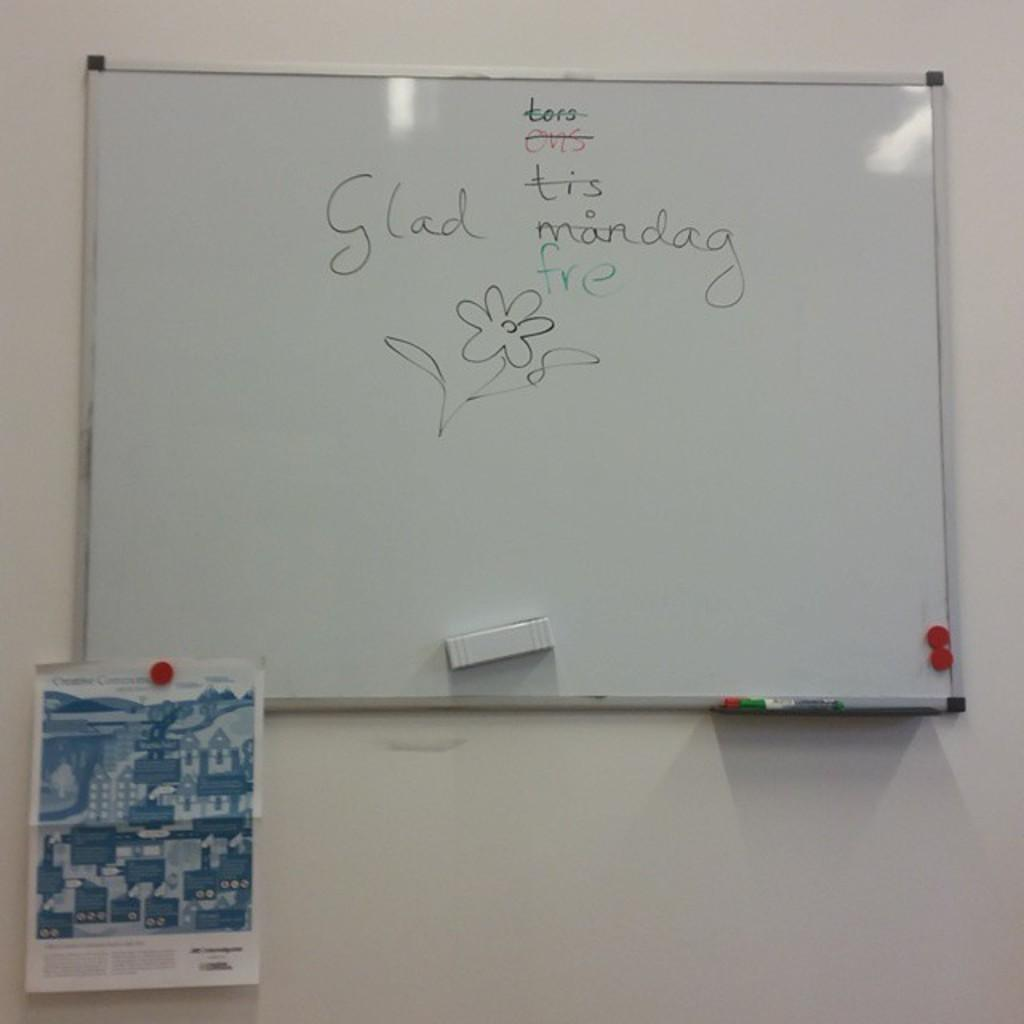<image>
Present a compact description of the photo's key features. A white board has a flower drawn on it and the word glad above it. 